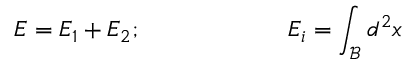Convert formula to latex. <formula><loc_0><loc_0><loc_500><loc_500>E = E _ { 1 } + E _ { 2 } ; \quad \ \ E _ { i } = \int _ { \mathcal { B } } d ^ { 2 } x</formula> 